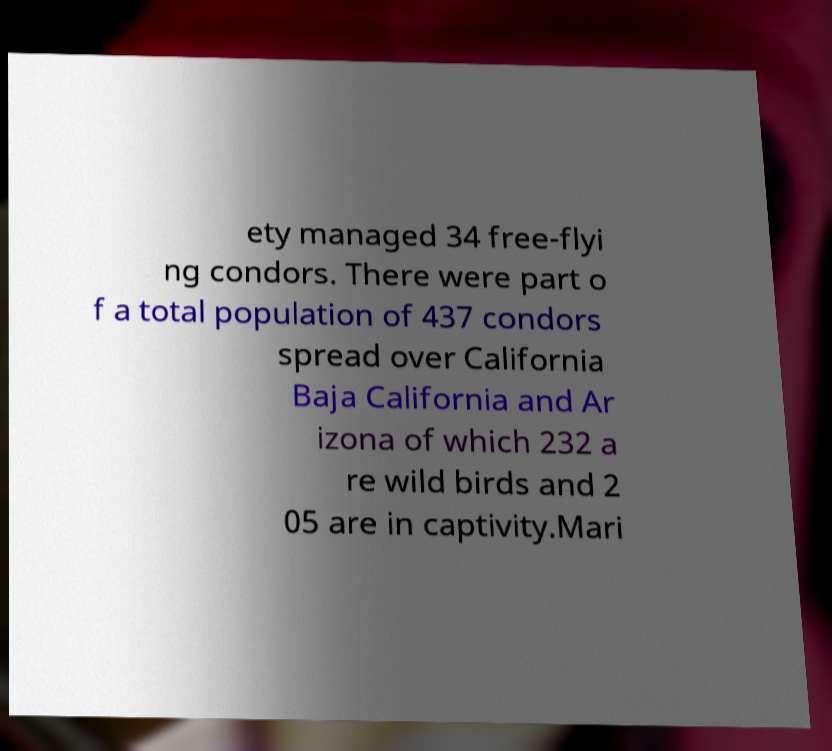Could you assist in decoding the text presented in this image and type it out clearly? ety managed 34 free-flyi ng condors. There were part o f a total population of 437 condors spread over California Baja California and Ar izona of which 232 a re wild birds and 2 05 are in captivity.Mari 